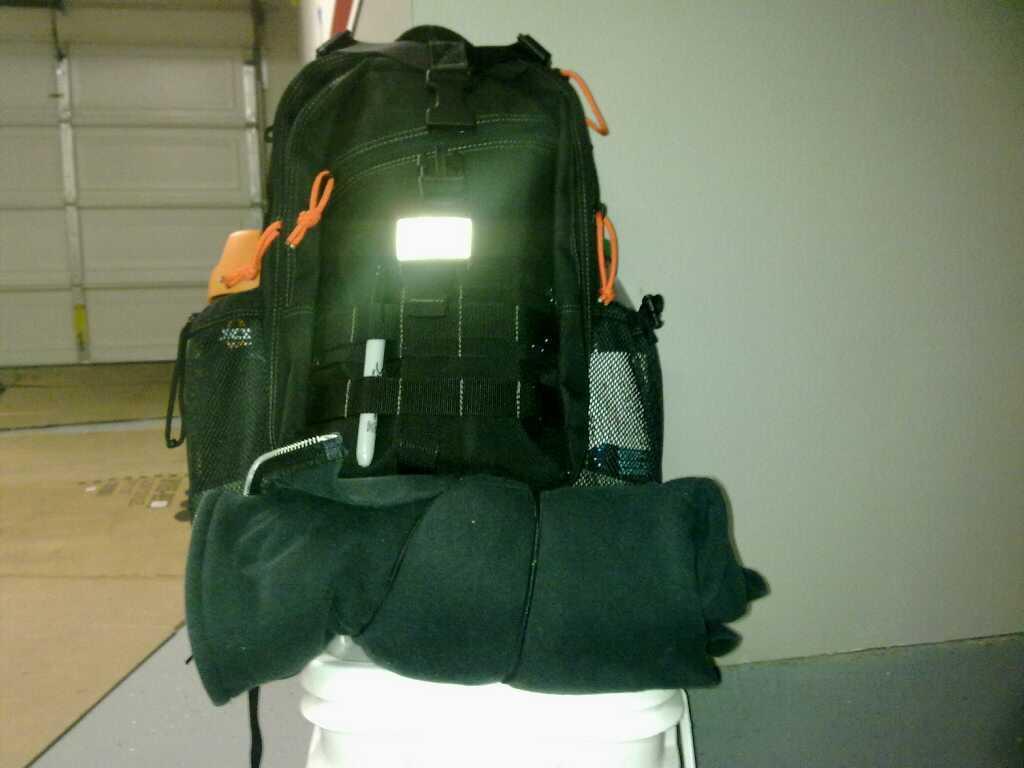Please provide a concise description of this image. This is the picture of a black bag under the bag there is a blanket and table. Background of this bag is a white wall. 